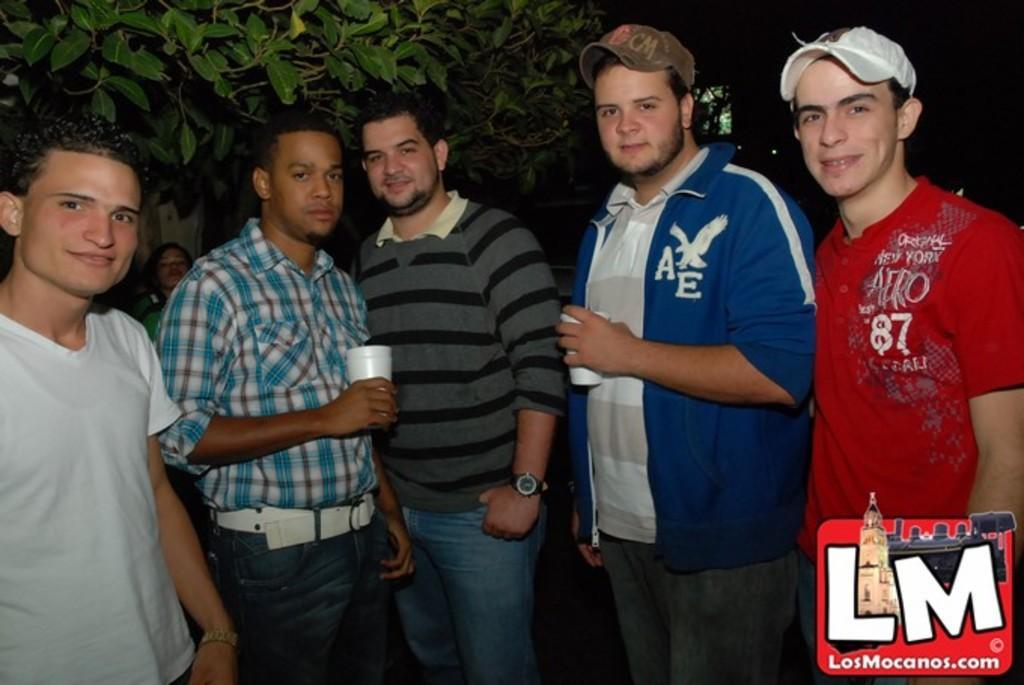Describe this image in one or two sentences. In the middle of this image, there are persons in different color dresses, smiling and standing. Two of them are holding, white color glasses. On the bottom right, there is a watermark. In the background, there is another person, there are trees and lights. And the background is dark in color. 